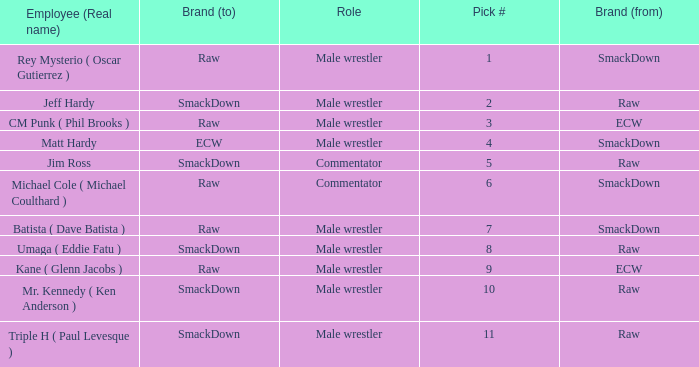Pick # 3 works for which brand? ECW. 